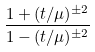Convert formula to latex. <formula><loc_0><loc_0><loc_500><loc_500>{ \frac { 1 + ( t / \mu ) ^ { \pm 2 } } { 1 - ( t / \mu ) ^ { \pm 2 } } }</formula> 